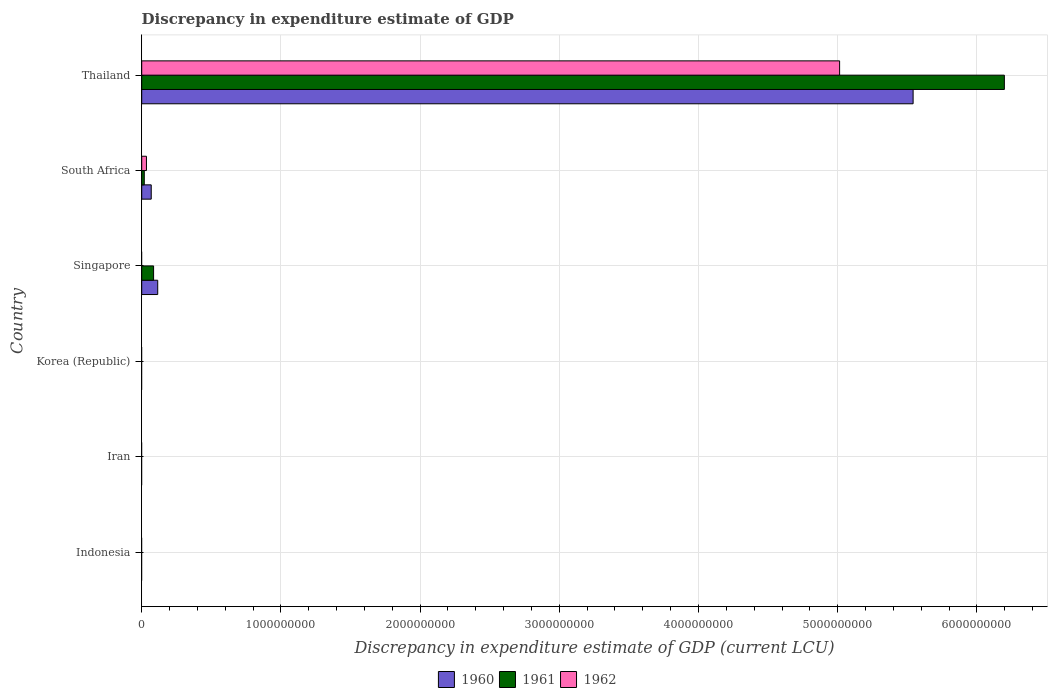How many bars are there on the 4th tick from the bottom?
Give a very brief answer. 2. What is the label of the 2nd group of bars from the top?
Ensure brevity in your answer.  South Africa. What is the discrepancy in expenditure estimate of GDP in 1962 in Thailand?
Offer a very short reply. 5.01e+09. Across all countries, what is the maximum discrepancy in expenditure estimate of GDP in 1962?
Give a very brief answer. 5.01e+09. In which country was the discrepancy in expenditure estimate of GDP in 1962 maximum?
Keep it short and to the point. Thailand. What is the total discrepancy in expenditure estimate of GDP in 1961 in the graph?
Give a very brief answer. 6.30e+09. What is the difference between the discrepancy in expenditure estimate of GDP in 1960 in Thailand and the discrepancy in expenditure estimate of GDP in 1962 in Korea (Republic)?
Your answer should be compact. 5.54e+09. What is the average discrepancy in expenditure estimate of GDP in 1962 per country?
Your answer should be compact. 8.41e+08. What is the difference between the discrepancy in expenditure estimate of GDP in 1962 and discrepancy in expenditure estimate of GDP in 1960 in South Africa?
Your answer should be very brief. -3.43e+07. In how many countries, is the discrepancy in expenditure estimate of GDP in 1962 greater than 4800000000 LCU?
Offer a terse response. 1. What is the ratio of the discrepancy in expenditure estimate of GDP in 1961 in South Africa to that in Thailand?
Offer a terse response. 0. Is the discrepancy in expenditure estimate of GDP in 1961 in South Africa less than that in Thailand?
Offer a very short reply. Yes. Is the difference between the discrepancy in expenditure estimate of GDP in 1962 in South Africa and Thailand greater than the difference between the discrepancy in expenditure estimate of GDP in 1960 in South Africa and Thailand?
Your answer should be compact. Yes. What is the difference between the highest and the second highest discrepancy in expenditure estimate of GDP in 1960?
Offer a very short reply. 5.43e+09. What is the difference between the highest and the lowest discrepancy in expenditure estimate of GDP in 1962?
Offer a very short reply. 5.01e+09. Are the values on the major ticks of X-axis written in scientific E-notation?
Provide a succinct answer. No. Does the graph contain any zero values?
Ensure brevity in your answer.  Yes. How many legend labels are there?
Keep it short and to the point. 3. How are the legend labels stacked?
Your answer should be compact. Horizontal. What is the title of the graph?
Provide a short and direct response. Discrepancy in expenditure estimate of GDP. Does "1983" appear as one of the legend labels in the graph?
Offer a very short reply. No. What is the label or title of the X-axis?
Ensure brevity in your answer.  Discrepancy in expenditure estimate of GDP (current LCU). What is the label or title of the Y-axis?
Provide a succinct answer. Country. What is the Discrepancy in expenditure estimate of GDP (current LCU) in 1961 in Indonesia?
Your answer should be compact. 0. What is the Discrepancy in expenditure estimate of GDP (current LCU) in 1960 in Iran?
Offer a terse response. 0. What is the Discrepancy in expenditure estimate of GDP (current LCU) of 1961 in Iran?
Ensure brevity in your answer.  0. What is the Discrepancy in expenditure estimate of GDP (current LCU) of 1962 in Korea (Republic)?
Your answer should be very brief. 0. What is the Discrepancy in expenditure estimate of GDP (current LCU) of 1960 in Singapore?
Provide a succinct answer. 1.15e+08. What is the Discrepancy in expenditure estimate of GDP (current LCU) in 1961 in Singapore?
Ensure brevity in your answer.  8.53e+07. What is the Discrepancy in expenditure estimate of GDP (current LCU) of 1960 in South Africa?
Give a very brief answer. 6.83e+07. What is the Discrepancy in expenditure estimate of GDP (current LCU) of 1961 in South Africa?
Offer a very short reply. 1.84e+07. What is the Discrepancy in expenditure estimate of GDP (current LCU) of 1962 in South Africa?
Keep it short and to the point. 3.40e+07. What is the Discrepancy in expenditure estimate of GDP (current LCU) in 1960 in Thailand?
Make the answer very short. 5.54e+09. What is the Discrepancy in expenditure estimate of GDP (current LCU) in 1961 in Thailand?
Offer a very short reply. 6.20e+09. What is the Discrepancy in expenditure estimate of GDP (current LCU) of 1962 in Thailand?
Make the answer very short. 5.01e+09. Across all countries, what is the maximum Discrepancy in expenditure estimate of GDP (current LCU) of 1960?
Keep it short and to the point. 5.54e+09. Across all countries, what is the maximum Discrepancy in expenditure estimate of GDP (current LCU) in 1961?
Provide a short and direct response. 6.20e+09. Across all countries, what is the maximum Discrepancy in expenditure estimate of GDP (current LCU) in 1962?
Provide a short and direct response. 5.01e+09. What is the total Discrepancy in expenditure estimate of GDP (current LCU) of 1960 in the graph?
Give a very brief answer. 5.72e+09. What is the total Discrepancy in expenditure estimate of GDP (current LCU) of 1961 in the graph?
Provide a short and direct response. 6.30e+09. What is the total Discrepancy in expenditure estimate of GDP (current LCU) in 1962 in the graph?
Ensure brevity in your answer.  5.05e+09. What is the difference between the Discrepancy in expenditure estimate of GDP (current LCU) of 1960 in Singapore and that in South Africa?
Give a very brief answer. 4.66e+07. What is the difference between the Discrepancy in expenditure estimate of GDP (current LCU) of 1961 in Singapore and that in South Africa?
Give a very brief answer. 6.69e+07. What is the difference between the Discrepancy in expenditure estimate of GDP (current LCU) in 1960 in Singapore and that in Thailand?
Make the answer very short. -5.43e+09. What is the difference between the Discrepancy in expenditure estimate of GDP (current LCU) in 1961 in Singapore and that in Thailand?
Your response must be concise. -6.11e+09. What is the difference between the Discrepancy in expenditure estimate of GDP (current LCU) in 1960 in South Africa and that in Thailand?
Provide a short and direct response. -5.47e+09. What is the difference between the Discrepancy in expenditure estimate of GDP (current LCU) of 1961 in South Africa and that in Thailand?
Provide a short and direct response. -6.18e+09. What is the difference between the Discrepancy in expenditure estimate of GDP (current LCU) of 1962 in South Africa and that in Thailand?
Ensure brevity in your answer.  -4.98e+09. What is the difference between the Discrepancy in expenditure estimate of GDP (current LCU) of 1960 in Singapore and the Discrepancy in expenditure estimate of GDP (current LCU) of 1961 in South Africa?
Offer a terse response. 9.65e+07. What is the difference between the Discrepancy in expenditure estimate of GDP (current LCU) in 1960 in Singapore and the Discrepancy in expenditure estimate of GDP (current LCU) in 1962 in South Africa?
Your response must be concise. 8.09e+07. What is the difference between the Discrepancy in expenditure estimate of GDP (current LCU) in 1961 in Singapore and the Discrepancy in expenditure estimate of GDP (current LCU) in 1962 in South Africa?
Make the answer very short. 5.13e+07. What is the difference between the Discrepancy in expenditure estimate of GDP (current LCU) in 1960 in Singapore and the Discrepancy in expenditure estimate of GDP (current LCU) in 1961 in Thailand?
Provide a succinct answer. -6.08e+09. What is the difference between the Discrepancy in expenditure estimate of GDP (current LCU) in 1960 in Singapore and the Discrepancy in expenditure estimate of GDP (current LCU) in 1962 in Thailand?
Your response must be concise. -4.90e+09. What is the difference between the Discrepancy in expenditure estimate of GDP (current LCU) in 1961 in Singapore and the Discrepancy in expenditure estimate of GDP (current LCU) in 1962 in Thailand?
Offer a very short reply. -4.93e+09. What is the difference between the Discrepancy in expenditure estimate of GDP (current LCU) of 1960 in South Africa and the Discrepancy in expenditure estimate of GDP (current LCU) of 1961 in Thailand?
Keep it short and to the point. -6.13e+09. What is the difference between the Discrepancy in expenditure estimate of GDP (current LCU) of 1960 in South Africa and the Discrepancy in expenditure estimate of GDP (current LCU) of 1962 in Thailand?
Your response must be concise. -4.95e+09. What is the difference between the Discrepancy in expenditure estimate of GDP (current LCU) in 1961 in South Africa and the Discrepancy in expenditure estimate of GDP (current LCU) in 1962 in Thailand?
Keep it short and to the point. -5.00e+09. What is the average Discrepancy in expenditure estimate of GDP (current LCU) of 1960 per country?
Offer a terse response. 9.54e+08. What is the average Discrepancy in expenditure estimate of GDP (current LCU) of 1961 per country?
Your answer should be very brief. 1.05e+09. What is the average Discrepancy in expenditure estimate of GDP (current LCU) of 1962 per country?
Give a very brief answer. 8.41e+08. What is the difference between the Discrepancy in expenditure estimate of GDP (current LCU) in 1960 and Discrepancy in expenditure estimate of GDP (current LCU) in 1961 in Singapore?
Provide a succinct answer. 2.96e+07. What is the difference between the Discrepancy in expenditure estimate of GDP (current LCU) of 1960 and Discrepancy in expenditure estimate of GDP (current LCU) of 1961 in South Africa?
Provide a short and direct response. 4.99e+07. What is the difference between the Discrepancy in expenditure estimate of GDP (current LCU) in 1960 and Discrepancy in expenditure estimate of GDP (current LCU) in 1962 in South Africa?
Your answer should be compact. 3.43e+07. What is the difference between the Discrepancy in expenditure estimate of GDP (current LCU) of 1961 and Discrepancy in expenditure estimate of GDP (current LCU) of 1962 in South Africa?
Make the answer very short. -1.56e+07. What is the difference between the Discrepancy in expenditure estimate of GDP (current LCU) in 1960 and Discrepancy in expenditure estimate of GDP (current LCU) in 1961 in Thailand?
Make the answer very short. -6.56e+08. What is the difference between the Discrepancy in expenditure estimate of GDP (current LCU) of 1960 and Discrepancy in expenditure estimate of GDP (current LCU) of 1962 in Thailand?
Provide a succinct answer. 5.28e+08. What is the difference between the Discrepancy in expenditure estimate of GDP (current LCU) of 1961 and Discrepancy in expenditure estimate of GDP (current LCU) of 1962 in Thailand?
Give a very brief answer. 1.18e+09. What is the ratio of the Discrepancy in expenditure estimate of GDP (current LCU) of 1960 in Singapore to that in South Africa?
Make the answer very short. 1.68. What is the ratio of the Discrepancy in expenditure estimate of GDP (current LCU) in 1961 in Singapore to that in South Africa?
Keep it short and to the point. 4.64. What is the ratio of the Discrepancy in expenditure estimate of GDP (current LCU) in 1960 in Singapore to that in Thailand?
Keep it short and to the point. 0.02. What is the ratio of the Discrepancy in expenditure estimate of GDP (current LCU) in 1961 in Singapore to that in Thailand?
Ensure brevity in your answer.  0.01. What is the ratio of the Discrepancy in expenditure estimate of GDP (current LCU) in 1960 in South Africa to that in Thailand?
Provide a short and direct response. 0.01. What is the ratio of the Discrepancy in expenditure estimate of GDP (current LCU) of 1961 in South Africa to that in Thailand?
Give a very brief answer. 0. What is the ratio of the Discrepancy in expenditure estimate of GDP (current LCU) in 1962 in South Africa to that in Thailand?
Keep it short and to the point. 0.01. What is the difference between the highest and the second highest Discrepancy in expenditure estimate of GDP (current LCU) in 1960?
Offer a very short reply. 5.43e+09. What is the difference between the highest and the second highest Discrepancy in expenditure estimate of GDP (current LCU) of 1961?
Your answer should be very brief. 6.11e+09. What is the difference between the highest and the lowest Discrepancy in expenditure estimate of GDP (current LCU) of 1960?
Give a very brief answer. 5.54e+09. What is the difference between the highest and the lowest Discrepancy in expenditure estimate of GDP (current LCU) of 1961?
Provide a succinct answer. 6.20e+09. What is the difference between the highest and the lowest Discrepancy in expenditure estimate of GDP (current LCU) of 1962?
Your response must be concise. 5.01e+09. 